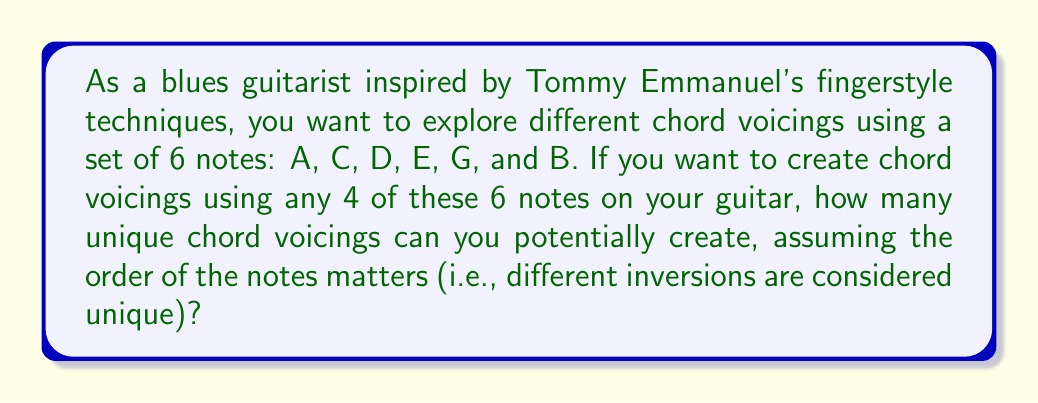Give your solution to this math problem. To solve this problem, we need to use the concept of permutations from group theory. Here's a step-by-step approach:

1. First, we need to calculate how many ways we can choose 4 notes out of the 6 available notes. This is a combination problem, denoted as $\binom{6}{4}$ or $C(6,4)$.

   $$\binom{6}{4} = \frac{6!}{4!(6-4)!} = \frac{6!}{4!2!} = 15$$

2. For each of these 15 combinations, we need to consider all possible permutations of the 4 chosen notes. This is because the order matters in chord voicings (different inversions are considered unique).

3. The number of permutations of 4 notes is simply 4!, which is:

   $$4! = 4 \times 3 \times 2 \times 1 = 24$$

4. By the multiplication principle, the total number of unique chord voicings is the product of the number of combinations and the number of permutations for each combination:

   $$\text{Total voicings} = \binom{6}{4} \times 4!$$

5. Substituting the values we calculated:

   $$\text{Total voicings} = 15 \times 24 = 360$$

Therefore, you can potentially create 360 unique chord voicings using any 4 of the 6 given notes, considering different inversions as unique.
Answer: 360 unique chord voicings 